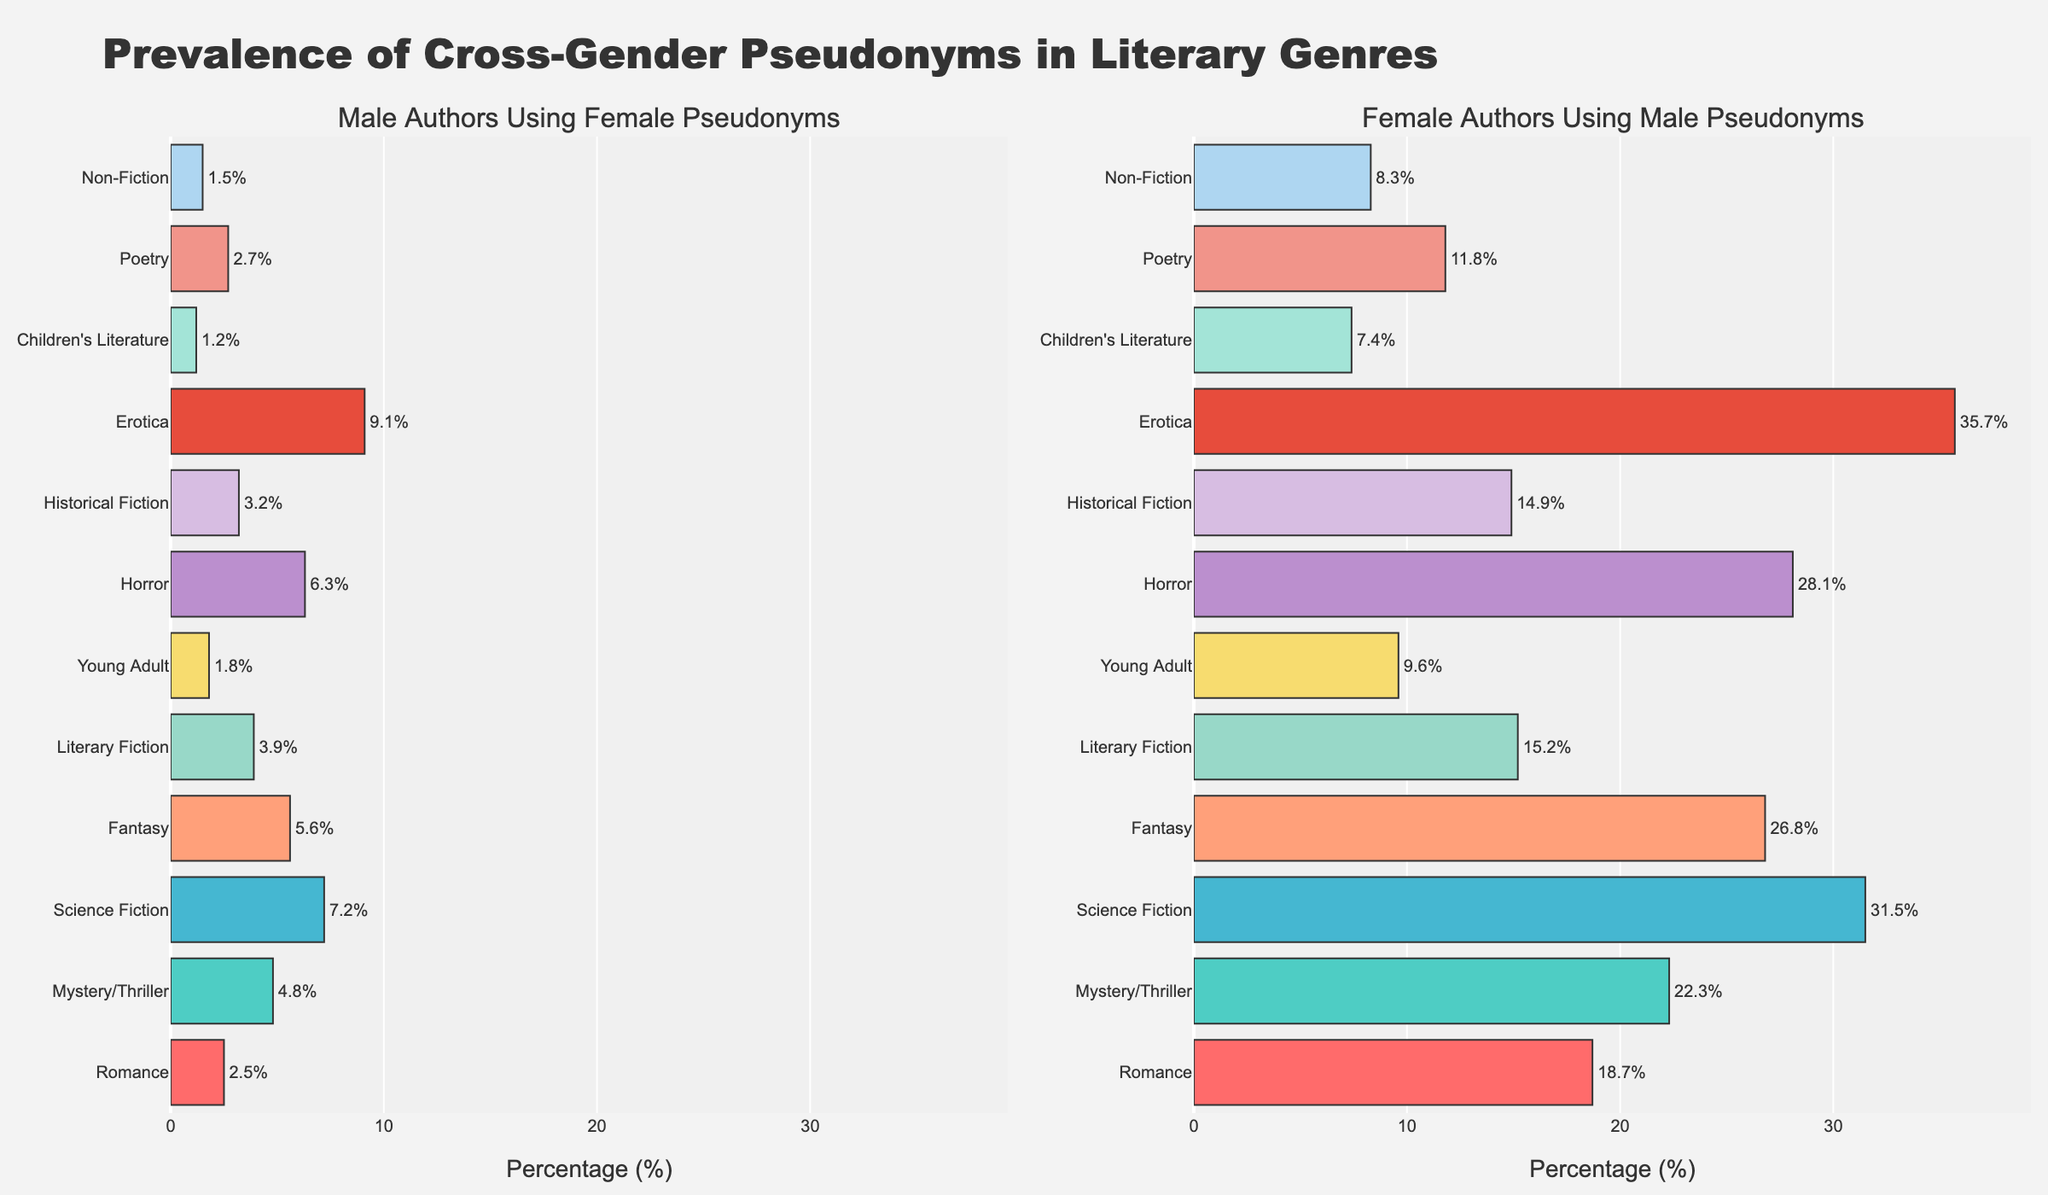Which genre has the highest percentage of male authors using female pseudonyms? Look at the bar chart for male authors using female pseudonyms. The bar for "Erotica" is the longest, which indicates the highest percentage.
Answer: Erotica Which genre has the lowest percentage of female authors using male pseudonyms? Look at the bar chart for female authors using male pseudonyms. The bar for "Children's Literature" is the shortest, indicating the lowest percentage.
Answer: Children's Literature What is the percentage difference between female authors using male pseudonyms in Romance and Science Fiction? Find the percentages for Romance (18.7%) and Science Fiction (31.5%). Subtract the smaller value from the larger one: 31.5% - 18.7% = 12.8%.
Answer: 12.8% Compare the prevalence of cross-gender pseudonyms in Historical Fiction and Non-Fiction for both male and female authors. Which genre shows a greater difference between the two groups? For Historical Fiction, male-to-female is 3.2% and female-to-male is 14.9%, a difference of 11.7%. For Non-Fiction, male-to-female is 1.5% and female-to-male is 8.3%, a difference of 6.8%. Historical Fiction has a greater difference.
Answer: Historical Fiction How many genres have a higher percentage of male authors using female pseudonyms than the average across all listed genres? Calculate the average percentage for male authors using female pseudonyms across all genres, then count how many individual genres exceed this average. The averages: Romance (2.5%), Mystery/Thriller (4.8%), Science Fiction (7.2%), Fantasy (5.6%), Literary Fiction (3.9%), Young Adult (1.8%), Horror (6.3%), Historical Fiction (3.2%), Erotica (9.1%), Children's Literature (1.2%), Poetry (2.7%), Non-Fiction (1.5%). The average is (2.5+4.8+7.2+5.6+3.9+1.8+6.3+3.2+9.1+1.2+2.7+1.5)/12 = 4.025%. Genres with higher percentages are: Science Fiction (7.2%), Fantasy (5.6%), Horror (6.3%), and Erotica (9.1%). Thus, 4 genres exceed the average.
Answer: 4 In which genre is the gap between male and female authors using cross-gender pseudonyms the smallest? Calculate the absolute difference in percentages between male and female authors using cross-gender pseudonyms for each genre. The differences are: Romance (16.2%), Mystery/Thriller (17.5%), Science Fiction (24.3%), Fantasy (21.2%), Literary Fiction (11.3%), Young Adult (7.8%), Horror (21.8%), Historical Fiction (11.7%), Erotica (26.6%), Children's Literature (6.2%), Poetry (9.1%), Non-Fiction (6.8%). The smallest difference is in Children's Literature with 6.2%.
Answer: Children's Literature Which two genres have the closest percentages of female authors using male pseudonyms? Compare the values for female authors using male pseudonyms. The percentages are: Romance (18.7%), Mystery/Thriller (22.3%), Science Fiction (31.5%), Fantasy (26.8%), Literary Fiction (15.2%), Young Adult (9.6%), Horror (28.1%), Historical Fiction (14.9%), Erotica (35.7%), Children's Literature (7.4%), Poetry (11.8%), Non-Fiction (8.3%). The two closest percentages are Literary Fiction (15.2%) and Historical Fiction (14.9%), with a difference of 0.3%.
Answer: Literary Fiction and Historical Fiction What is the average percentage of female authors using male pseudonyms across all genres? Sum the percentages for each genre and divide by the number of genres: (18.7 + 22.3 + 31.5 + 26.8 + 15.2 + 9.6 + 28.1 + 14.9 + 35.7 + 7.4 + 11.8 + 8.3) / 12 = 19.825%.
Answer: 19.8% 